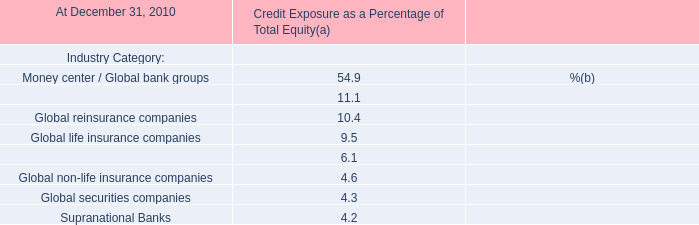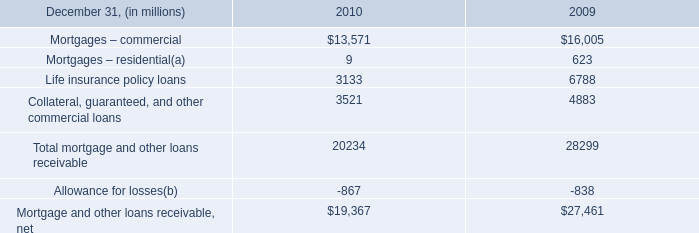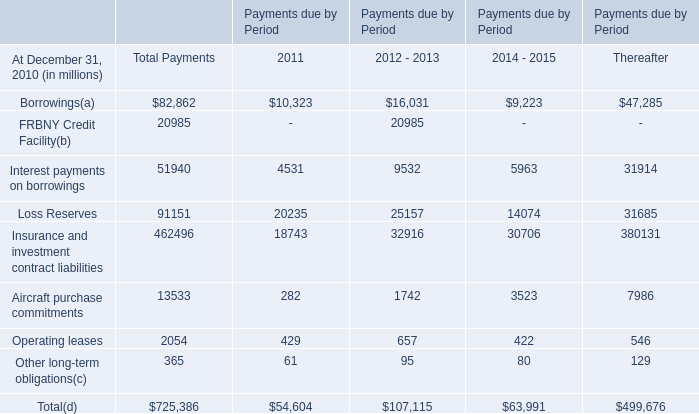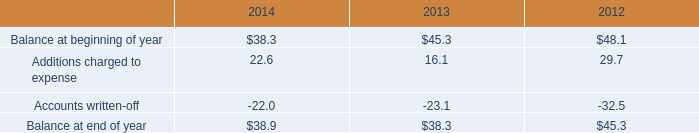What's the sum of Loss Reserves of Payments due by Period Thereafter, and Mortgages – commercial of 2009 ? 
Computations: (31685.0 + 16005.0)
Answer: 47690.0. 